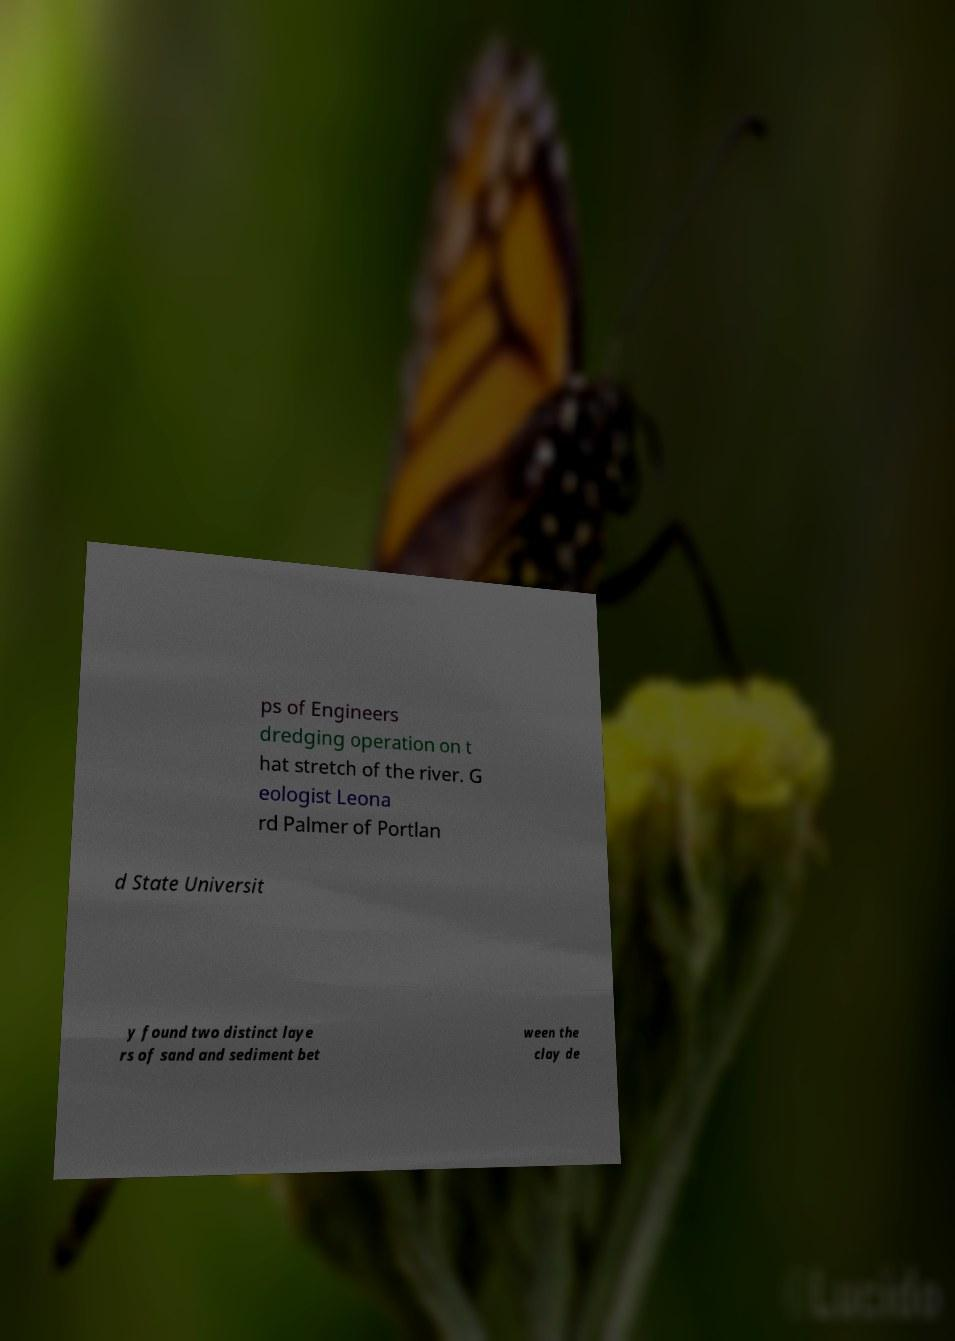Please identify and transcribe the text found in this image. ps of Engineers dredging operation on t hat stretch of the river. G eologist Leona rd Palmer of Portlan d State Universit y found two distinct laye rs of sand and sediment bet ween the clay de 